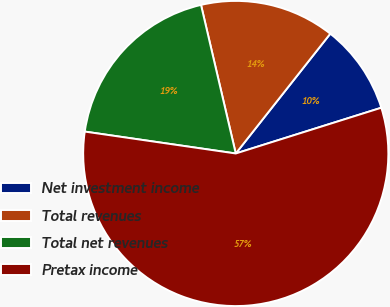<chart> <loc_0><loc_0><loc_500><loc_500><pie_chart><fcel>Net investment income<fcel>Total revenues<fcel>Total net revenues<fcel>Pretax income<nl><fcel>9.52%<fcel>14.29%<fcel>19.05%<fcel>57.14%<nl></chart> 